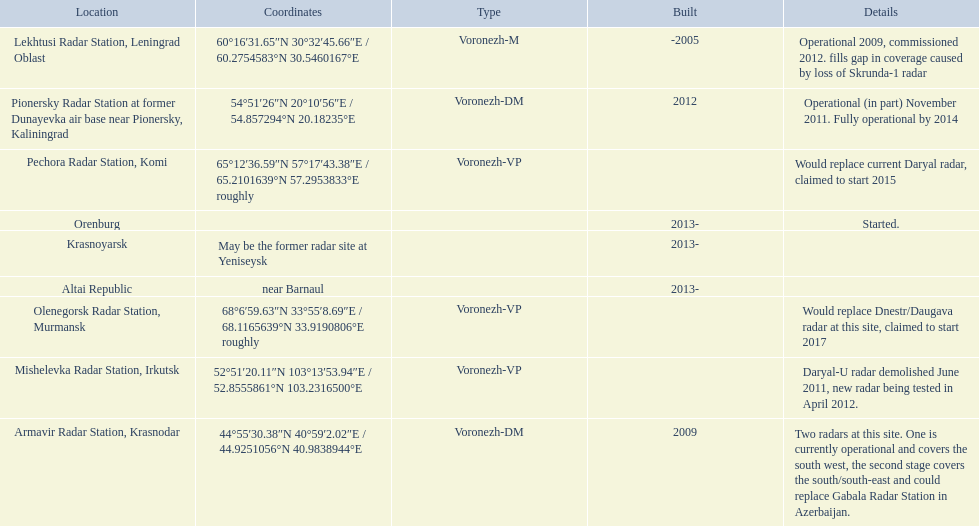Voronezh radar has locations where? Lekhtusi Radar Station, Leningrad Oblast, Armavir Radar Station, Krasnodar, Pionersky Radar Station at former Dunayevka air base near Pionersky, Kaliningrad, Mishelevka Radar Station, Irkutsk, Pechora Radar Station, Komi, Olenegorsk Radar Station, Murmansk, Krasnoyarsk, Altai Republic, Orenburg. Which of these locations have know coordinates? Lekhtusi Radar Station, Leningrad Oblast, Armavir Radar Station, Krasnodar, Pionersky Radar Station at former Dunayevka air base near Pionersky, Kaliningrad, Mishelevka Radar Station, Irkutsk, Pechora Radar Station, Komi, Olenegorsk Radar Station, Murmansk. Which of these locations has coordinates of 60deg16'31.65''n 30deg32'45.66''e / 60.2754583degn 30.5460167dege? Lekhtusi Radar Station, Leningrad Oblast. 